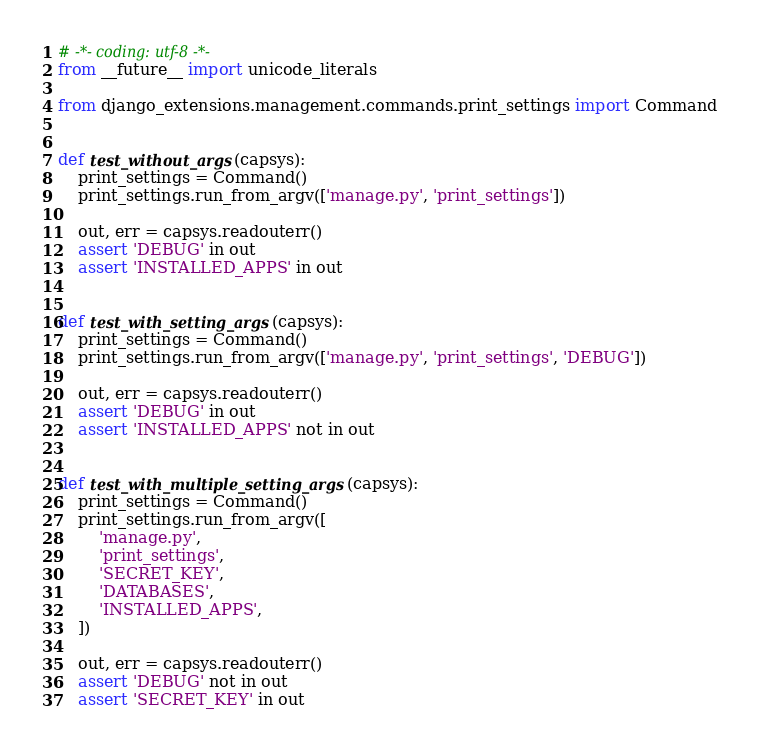Convert code to text. <code><loc_0><loc_0><loc_500><loc_500><_Python_># -*- coding: utf-8 -*-
from __future__ import unicode_literals

from django_extensions.management.commands.print_settings import Command


def test_without_args(capsys):
    print_settings = Command()
    print_settings.run_from_argv(['manage.py', 'print_settings'])

    out, err = capsys.readouterr()
    assert 'DEBUG' in out
    assert 'INSTALLED_APPS' in out


def test_with_setting_args(capsys):
    print_settings = Command()
    print_settings.run_from_argv(['manage.py', 'print_settings', 'DEBUG'])

    out, err = capsys.readouterr()
    assert 'DEBUG' in out
    assert 'INSTALLED_APPS' not in out


def test_with_multiple_setting_args(capsys):
    print_settings = Command()
    print_settings.run_from_argv([
        'manage.py',
        'print_settings',
        'SECRET_KEY',
        'DATABASES',
        'INSTALLED_APPS',
    ])

    out, err = capsys.readouterr()
    assert 'DEBUG' not in out
    assert 'SECRET_KEY' in out</code> 